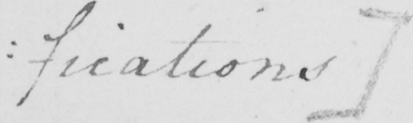Please provide the text content of this handwritten line. : fications ] 